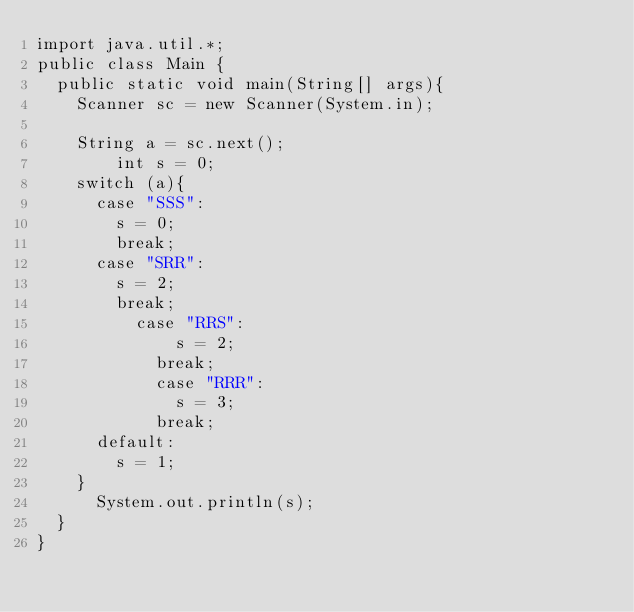Convert code to text. <code><loc_0><loc_0><loc_500><loc_500><_Java_>import java.util.*;
public class Main {
	public static void main(String[] args){
		Scanner sc = new Scanner(System.in);
		
		String a = sc.next();
      	int s = 0;
		switch (a){
			case "SSS":
				s = 0;
				break;
			case "SRR":
				s = 2;
				break;
          case "RRS":
            	s = 2;
            break;
          	case "RRR":
            	s = 3;
            break;
			default:
				s = 1;
		}
      System.out.println(s);
	}
}</code> 